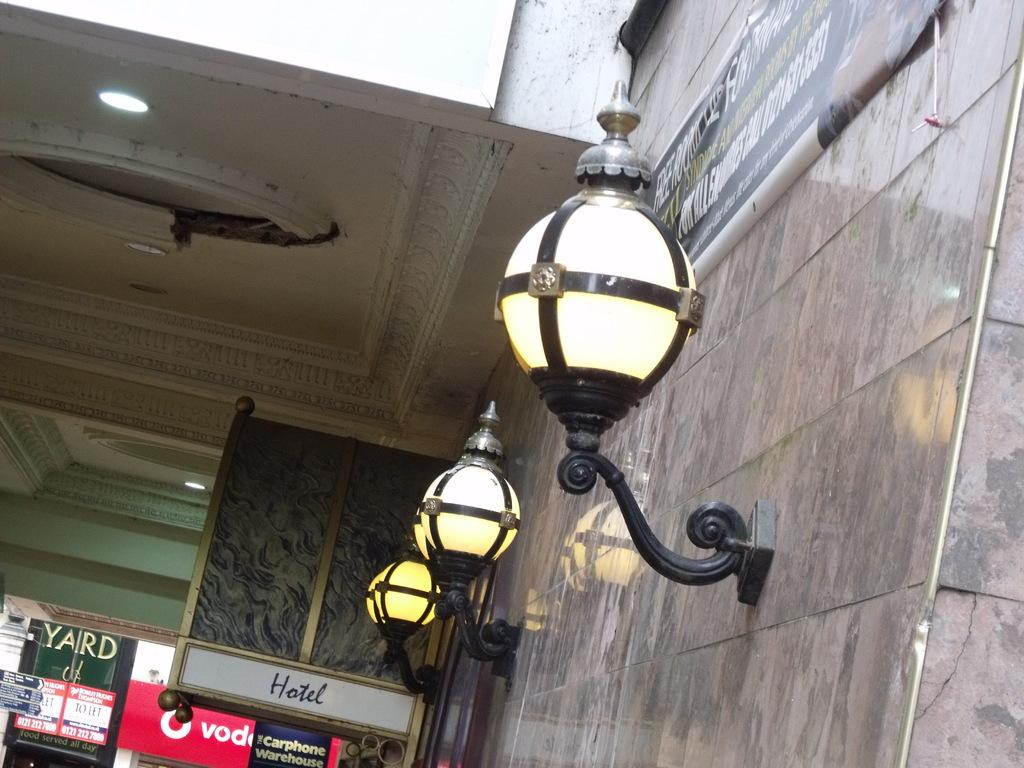What can be seen on the wall in the image? There are lights and banners on the wall in the image. What other structures are present in the image? There are hoardings in the image. What is visible on the ceiling in the image? There are designs and lights on the ceiling in the image. What type of coat is hanging on the wall in the image? There is no coat present in the image. How many turkeys can be seen on the ceiling in the image? There are no turkeys present in the image; only lights and designs are visible on the ceiling. 